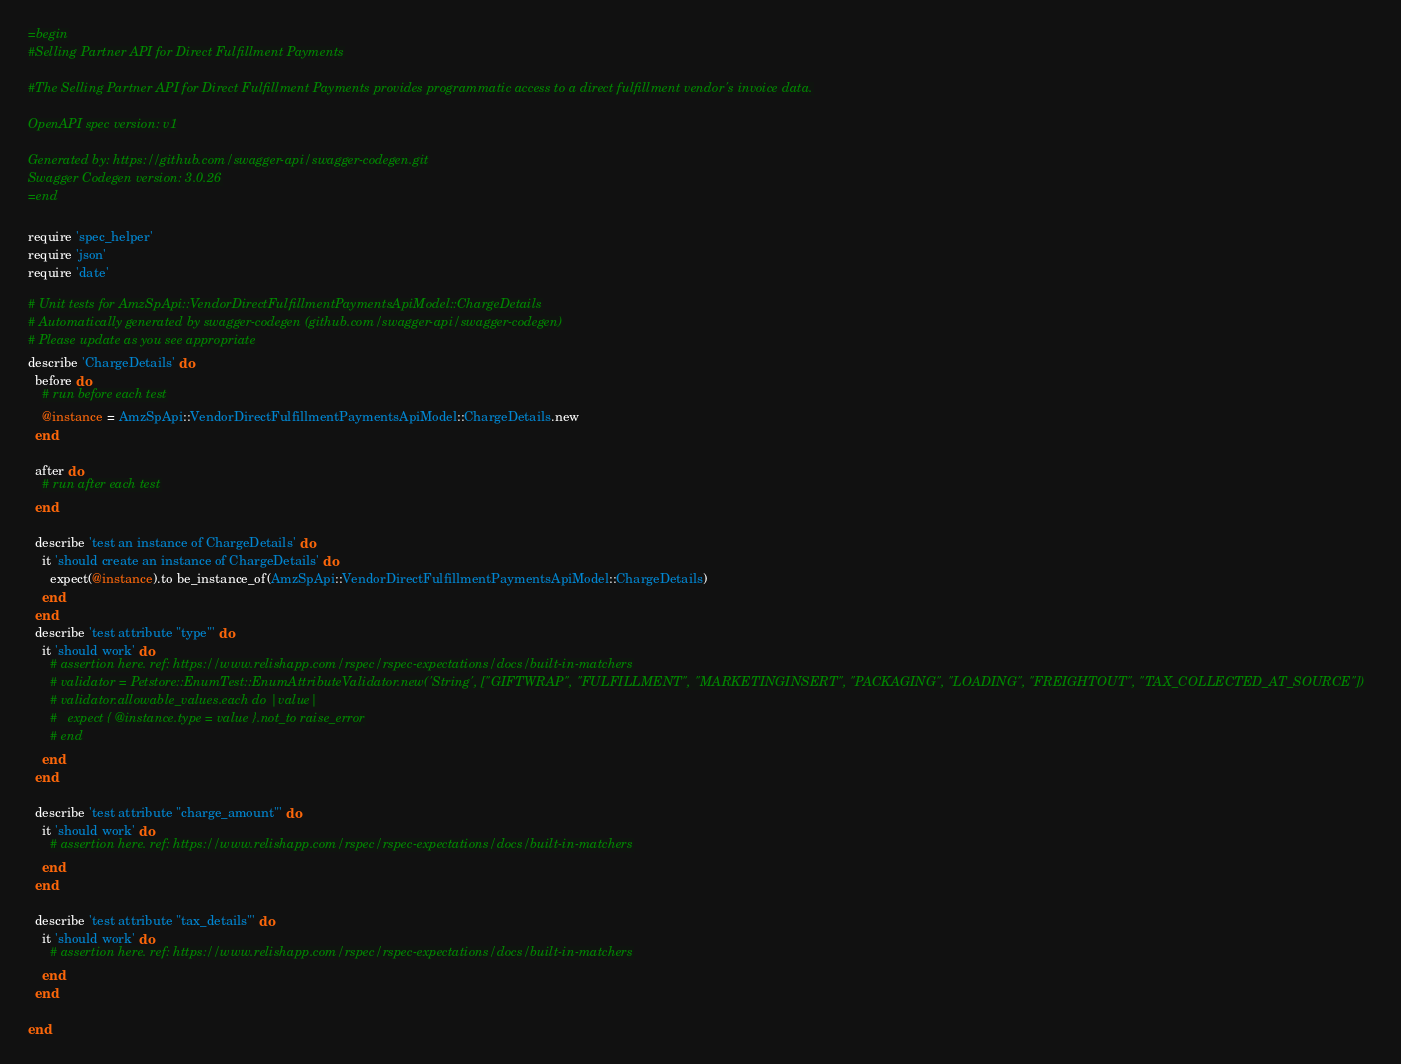<code> <loc_0><loc_0><loc_500><loc_500><_Ruby_>=begin
#Selling Partner API for Direct Fulfillment Payments

#The Selling Partner API for Direct Fulfillment Payments provides programmatic access to a direct fulfillment vendor's invoice data.

OpenAPI spec version: v1

Generated by: https://github.com/swagger-api/swagger-codegen.git
Swagger Codegen version: 3.0.26
=end

require 'spec_helper'
require 'json'
require 'date'

# Unit tests for AmzSpApi::VendorDirectFulfillmentPaymentsApiModel::ChargeDetails
# Automatically generated by swagger-codegen (github.com/swagger-api/swagger-codegen)
# Please update as you see appropriate
describe 'ChargeDetails' do
  before do
    # run before each test
    @instance = AmzSpApi::VendorDirectFulfillmentPaymentsApiModel::ChargeDetails.new
  end

  after do
    # run after each test
  end

  describe 'test an instance of ChargeDetails' do
    it 'should create an instance of ChargeDetails' do
      expect(@instance).to be_instance_of(AmzSpApi::VendorDirectFulfillmentPaymentsApiModel::ChargeDetails)
    end
  end
  describe 'test attribute "type"' do
    it 'should work' do
      # assertion here. ref: https://www.relishapp.com/rspec/rspec-expectations/docs/built-in-matchers
      # validator = Petstore::EnumTest::EnumAttributeValidator.new('String', ["GIFTWRAP", "FULFILLMENT", "MARKETINGINSERT", "PACKAGING", "LOADING", "FREIGHTOUT", "TAX_COLLECTED_AT_SOURCE"])
      # validator.allowable_values.each do |value|
      #   expect { @instance.type = value }.not_to raise_error
      # end
    end
  end

  describe 'test attribute "charge_amount"' do
    it 'should work' do
      # assertion here. ref: https://www.relishapp.com/rspec/rspec-expectations/docs/built-in-matchers
    end
  end

  describe 'test attribute "tax_details"' do
    it 'should work' do
      # assertion here. ref: https://www.relishapp.com/rspec/rspec-expectations/docs/built-in-matchers
    end
  end

end
</code> 